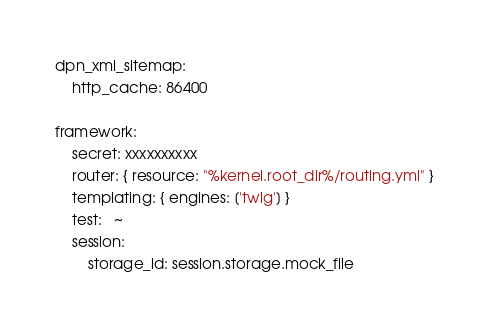Convert code to text. <code><loc_0><loc_0><loc_500><loc_500><_YAML_>dpn_xml_sitemap:
    http_cache: 86400

framework:
    secret: xxxxxxxxxx
    router: { resource: "%kernel.root_dir%/routing.yml" }
    templating: { engines: ['twig'] }
    test:   ~
    session:
        storage_id: session.storage.mock_file
</code> 